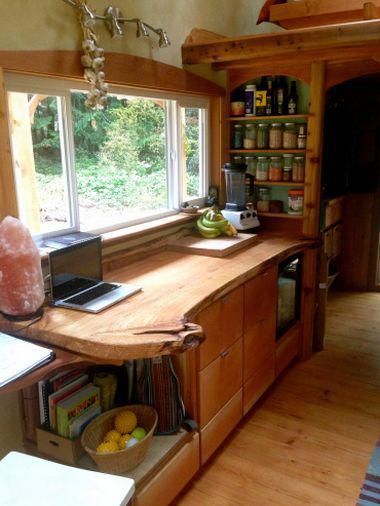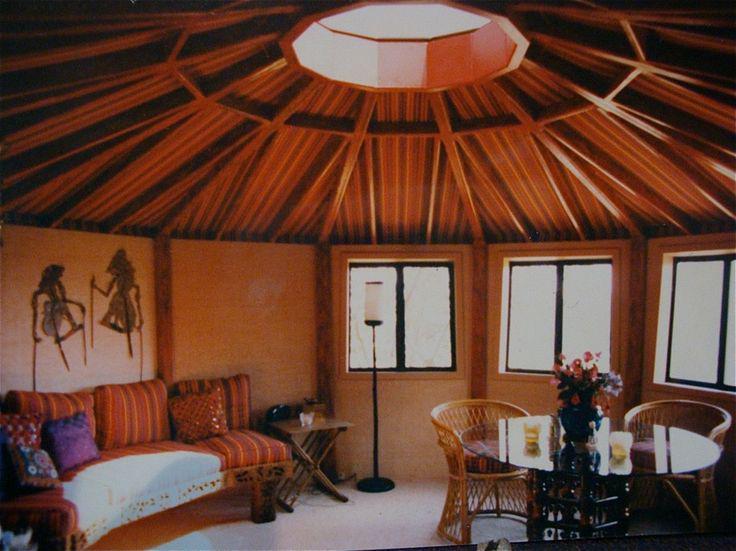The first image is the image on the left, the second image is the image on the right. For the images shown, is this caption "An image of a yurt's interior shows a wood slab countertop that ends with a curving corner." true? Answer yes or no. Yes. The first image is the image on the left, the second image is the image on the right. Assess this claim about the two images: "In one image, a white kitchen sink is built into a wooden cabinet, and is situated in front of a window near wall shelves stocked with kitchen supplies.". Correct or not? Answer yes or no. No. 